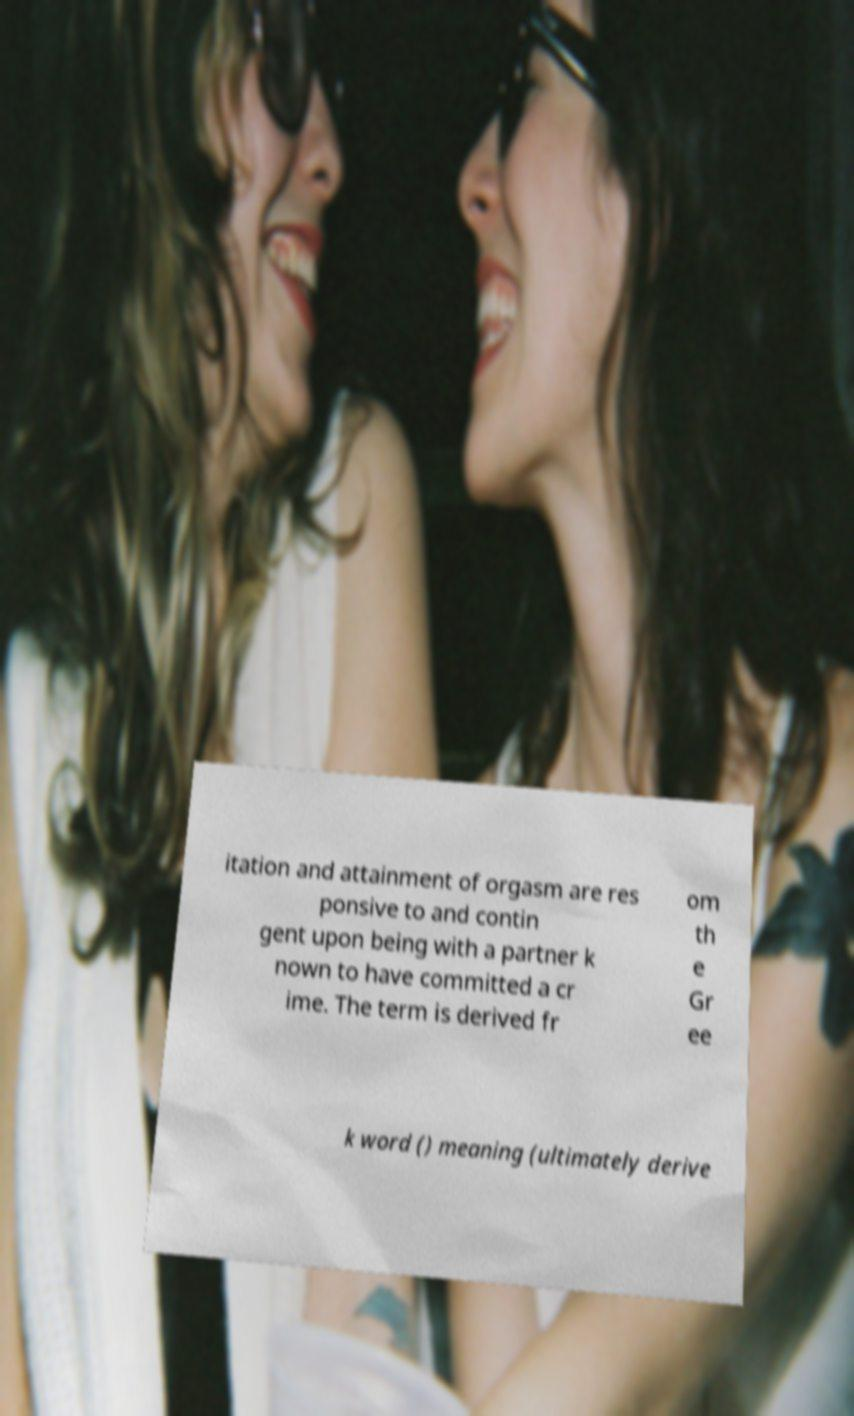Please identify and transcribe the text found in this image. itation and attainment of orgasm are res ponsive to and contin gent upon being with a partner k nown to have committed a cr ime. The term is derived fr om th e Gr ee k word () meaning (ultimately derive 